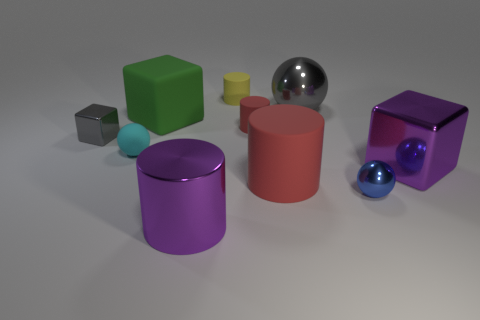Subtract 1 cylinders. How many cylinders are left? 3 Subtract all spheres. How many objects are left? 7 Add 9 big blue things. How many big blue things exist? 9 Subtract 1 cyan balls. How many objects are left? 9 Subtract all brown rubber blocks. Subtract all small gray things. How many objects are left? 9 Add 5 matte cubes. How many matte cubes are left? 6 